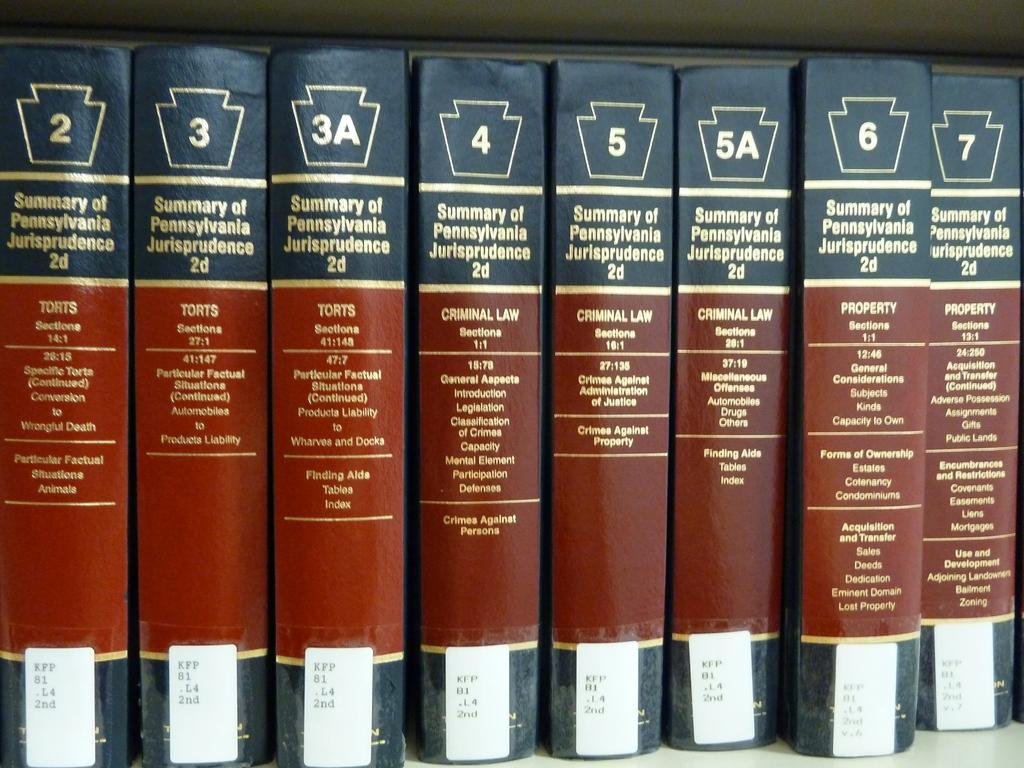<image>
Offer a succinct explanation of the picture presented. A set of books are numbered from two to seven and are lined up in a row. 